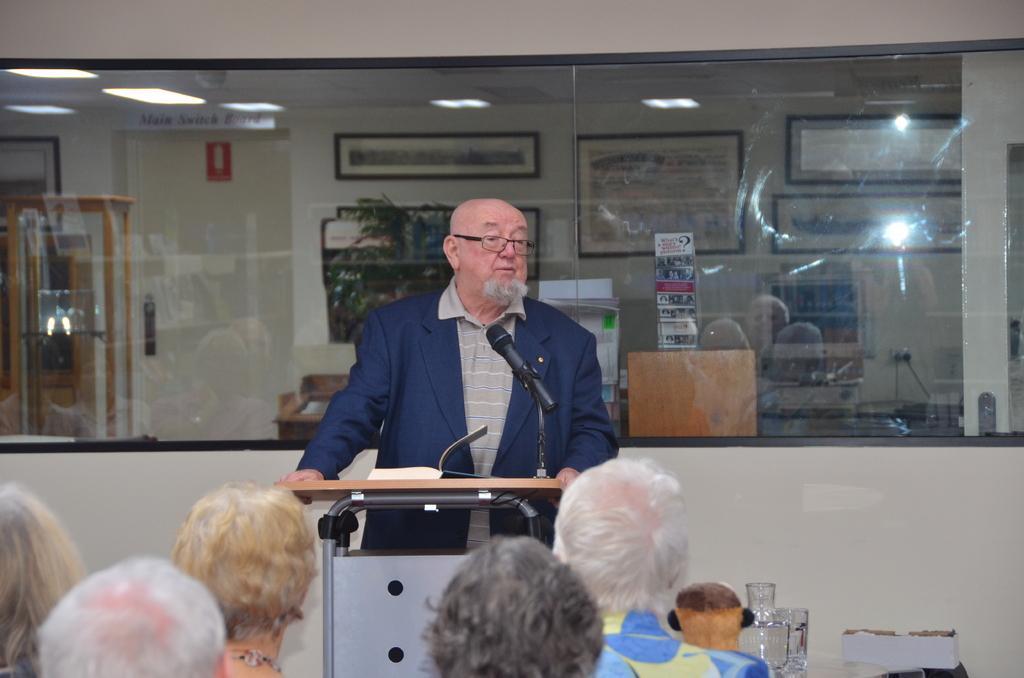In one or two sentences, can you explain what this image depicts? In this picture I can see there is a man standing and speaking here and there is a water jar and glasses on to right side. There is a wooden table and a microphone in front of him. In the backdrop there is a wall and a glass window. There are few people sitting here. 